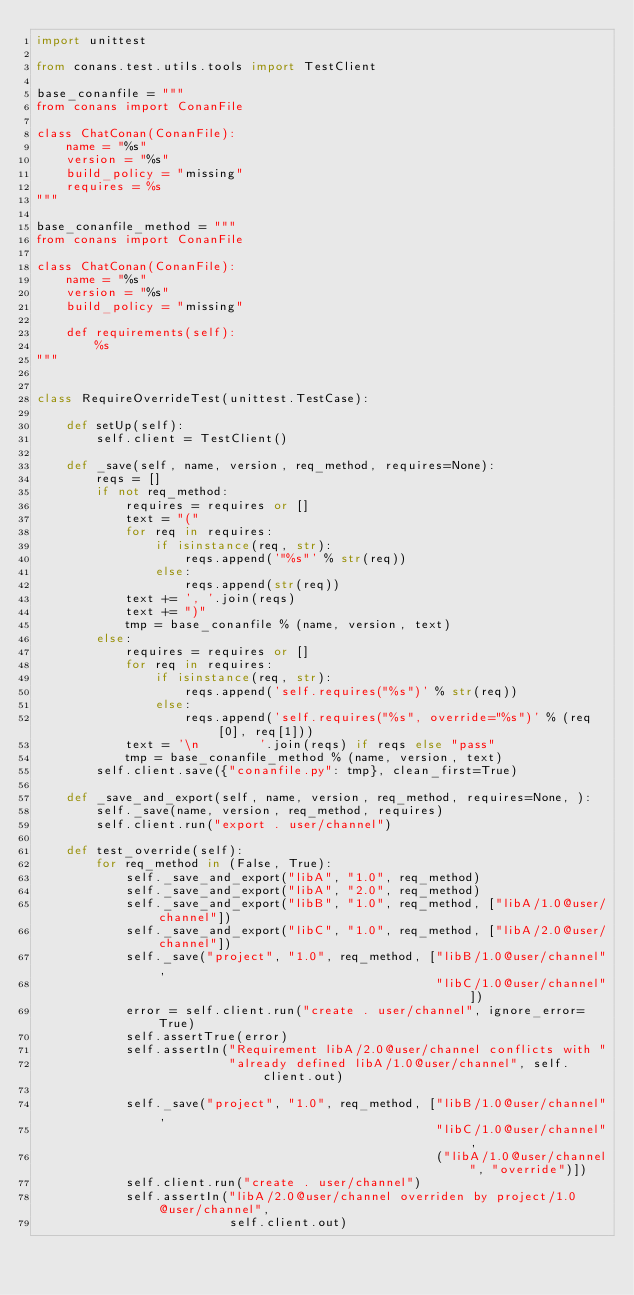Convert code to text. <code><loc_0><loc_0><loc_500><loc_500><_Python_>import unittest

from conans.test.utils.tools import TestClient

base_conanfile = """
from conans import ConanFile

class ChatConan(ConanFile):
    name = "%s"
    version = "%s"
    build_policy = "missing"
    requires = %s
"""

base_conanfile_method = """
from conans import ConanFile

class ChatConan(ConanFile):
    name = "%s"
    version = "%s"
    build_policy = "missing"
    
    def requirements(self):
        %s
"""


class RequireOverrideTest(unittest.TestCase):

    def setUp(self):
        self.client = TestClient()

    def _save(self, name, version, req_method, requires=None):
        reqs = []
        if not req_method:
            requires = requires or []
            text = "("
            for req in requires:
                if isinstance(req, str):
                    reqs.append('"%s"' % str(req))
                else:
                    reqs.append(str(req))
            text += ', '.join(reqs)
            text += ")"
            tmp = base_conanfile % (name, version, text)
        else:
            requires = requires or []
            for req in requires:
                if isinstance(req, str):
                    reqs.append('self.requires("%s")' % str(req))
                else:
                    reqs.append('self.requires("%s", override="%s")' % (req[0], req[1]))
            text = '\n        '.join(reqs) if reqs else "pass"
            tmp = base_conanfile_method % (name, version, text)
        self.client.save({"conanfile.py": tmp}, clean_first=True)

    def _save_and_export(self, name, version, req_method, requires=None, ):
        self._save(name, version, req_method, requires)
        self.client.run("export . user/channel")

    def test_override(self):
        for req_method in (False, True):
            self._save_and_export("libA", "1.0", req_method)
            self._save_and_export("libA", "2.0", req_method)
            self._save_and_export("libB", "1.0", req_method, ["libA/1.0@user/channel"])
            self._save_and_export("libC", "1.0", req_method, ["libA/2.0@user/channel"])
            self._save("project", "1.0", req_method, ["libB/1.0@user/channel",
                                                      "libC/1.0@user/channel"])
            error = self.client.run("create . user/channel", ignore_error=True)
            self.assertTrue(error)
            self.assertIn("Requirement libA/2.0@user/channel conflicts with "
                          "already defined libA/1.0@user/channel", self.client.out)

            self._save("project", "1.0", req_method, ["libB/1.0@user/channel",
                                                      "libC/1.0@user/channel",
                                                      ("libA/1.0@user/channel", "override")])
            self.client.run("create . user/channel")
            self.assertIn("libA/2.0@user/channel overriden by project/1.0@user/channel",
                          self.client.out)
</code> 